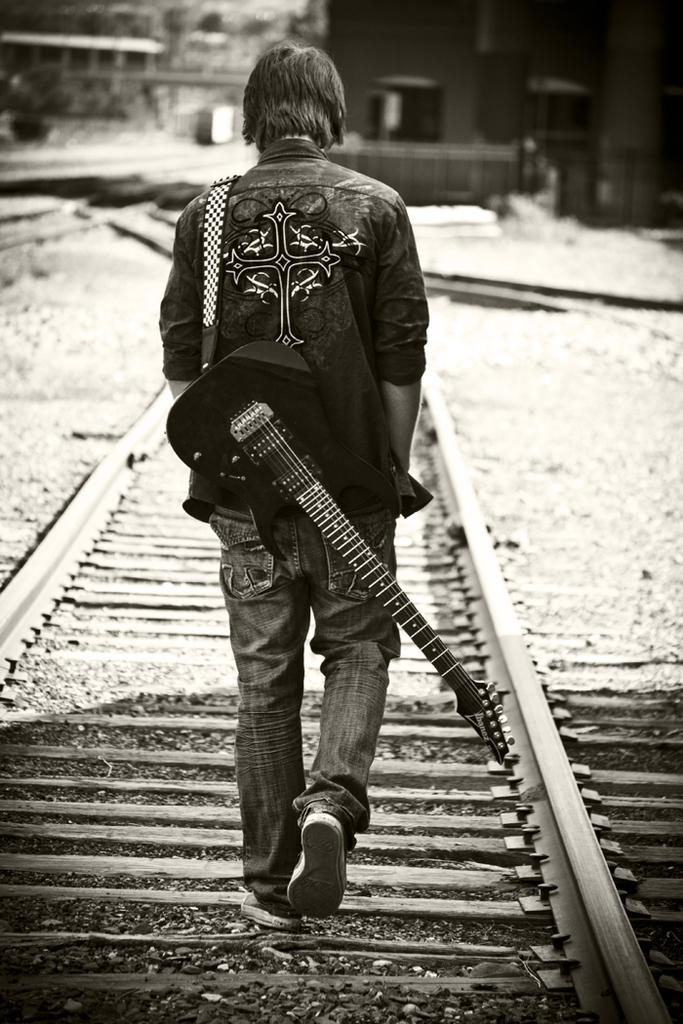What is the color scheme of the image? The image is black and white. What is the person in the image doing? The person is walking on the railway track. What is the person wearing that is related to music? The person is wearing a guitar belt. What can be seen in the distance behind the person? The background of the image is blurred, but there are buildings visible in the background. How many parcels is the person carrying in the image? There is no parcel visible in the image; the person is only wearing a guitar belt. What type of linen is draped over the buildings in the background? There is no linen present in the image; the buildings in the background are visible but not covered by any fabric. 